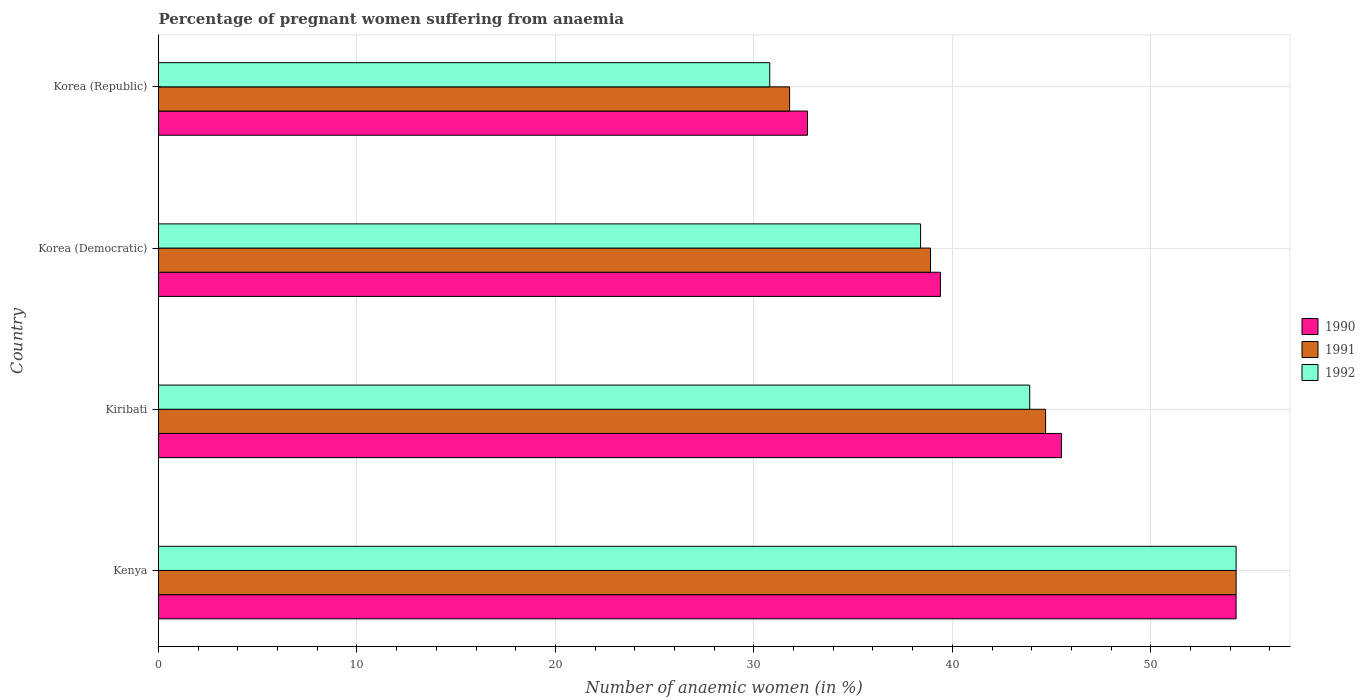How many groups of bars are there?
Give a very brief answer. 4. Are the number of bars per tick equal to the number of legend labels?
Offer a very short reply. Yes. Are the number of bars on each tick of the Y-axis equal?
Keep it short and to the point. Yes. How many bars are there on the 3rd tick from the bottom?
Provide a short and direct response. 3. What is the label of the 1st group of bars from the top?
Offer a terse response. Korea (Republic). In how many cases, is the number of bars for a given country not equal to the number of legend labels?
Make the answer very short. 0. What is the number of anaemic women in 1990 in Kenya?
Give a very brief answer. 54.3. Across all countries, what is the maximum number of anaemic women in 1992?
Provide a succinct answer. 54.3. Across all countries, what is the minimum number of anaemic women in 1992?
Your answer should be very brief. 30.8. In which country was the number of anaemic women in 1990 maximum?
Give a very brief answer. Kenya. In which country was the number of anaemic women in 1991 minimum?
Offer a terse response. Korea (Republic). What is the total number of anaemic women in 1992 in the graph?
Make the answer very short. 167.4. What is the difference between the number of anaemic women in 1992 in Kiribati and that in Korea (Republic)?
Your response must be concise. 13.1. What is the difference between the number of anaemic women in 1992 in Korea (Democratic) and the number of anaemic women in 1990 in Kenya?
Ensure brevity in your answer.  -15.9. What is the average number of anaemic women in 1992 per country?
Your answer should be very brief. 41.85. What is the difference between the number of anaemic women in 1991 and number of anaemic women in 1990 in Kenya?
Offer a very short reply. 0. In how many countries, is the number of anaemic women in 1990 greater than 6 %?
Provide a succinct answer. 4. What is the ratio of the number of anaemic women in 1991 in Kiribati to that in Korea (Democratic)?
Your answer should be compact. 1.15. Is the number of anaemic women in 1992 in Kenya less than that in Korea (Republic)?
Ensure brevity in your answer.  No. What is the difference between the highest and the second highest number of anaemic women in 1991?
Your response must be concise. 9.6. What is the difference between the highest and the lowest number of anaemic women in 1991?
Provide a succinct answer. 22.5. In how many countries, is the number of anaemic women in 1992 greater than the average number of anaemic women in 1992 taken over all countries?
Your answer should be compact. 2. What does the 3rd bar from the top in Kenya represents?
Keep it short and to the point. 1990. Are all the bars in the graph horizontal?
Provide a short and direct response. Yes. How many countries are there in the graph?
Your answer should be compact. 4. What is the difference between two consecutive major ticks on the X-axis?
Provide a short and direct response. 10. Are the values on the major ticks of X-axis written in scientific E-notation?
Provide a short and direct response. No. Where does the legend appear in the graph?
Your answer should be compact. Center right. How are the legend labels stacked?
Provide a short and direct response. Vertical. What is the title of the graph?
Your response must be concise. Percentage of pregnant women suffering from anaemia. Does "2002" appear as one of the legend labels in the graph?
Your response must be concise. No. What is the label or title of the X-axis?
Give a very brief answer. Number of anaemic women (in %). What is the label or title of the Y-axis?
Ensure brevity in your answer.  Country. What is the Number of anaemic women (in %) of 1990 in Kenya?
Your answer should be compact. 54.3. What is the Number of anaemic women (in %) in 1991 in Kenya?
Keep it short and to the point. 54.3. What is the Number of anaemic women (in %) of 1992 in Kenya?
Offer a very short reply. 54.3. What is the Number of anaemic women (in %) in 1990 in Kiribati?
Your answer should be compact. 45.5. What is the Number of anaemic women (in %) of 1991 in Kiribati?
Make the answer very short. 44.7. What is the Number of anaemic women (in %) in 1992 in Kiribati?
Ensure brevity in your answer.  43.9. What is the Number of anaemic women (in %) in 1990 in Korea (Democratic)?
Your answer should be very brief. 39.4. What is the Number of anaemic women (in %) of 1991 in Korea (Democratic)?
Make the answer very short. 38.9. What is the Number of anaemic women (in %) in 1992 in Korea (Democratic)?
Your answer should be compact. 38.4. What is the Number of anaemic women (in %) in 1990 in Korea (Republic)?
Your answer should be very brief. 32.7. What is the Number of anaemic women (in %) of 1991 in Korea (Republic)?
Provide a short and direct response. 31.8. What is the Number of anaemic women (in %) in 1992 in Korea (Republic)?
Your answer should be compact. 30.8. Across all countries, what is the maximum Number of anaemic women (in %) of 1990?
Make the answer very short. 54.3. Across all countries, what is the maximum Number of anaemic women (in %) in 1991?
Your answer should be compact. 54.3. Across all countries, what is the maximum Number of anaemic women (in %) in 1992?
Make the answer very short. 54.3. Across all countries, what is the minimum Number of anaemic women (in %) of 1990?
Ensure brevity in your answer.  32.7. Across all countries, what is the minimum Number of anaemic women (in %) in 1991?
Give a very brief answer. 31.8. Across all countries, what is the minimum Number of anaemic women (in %) of 1992?
Keep it short and to the point. 30.8. What is the total Number of anaemic women (in %) of 1990 in the graph?
Your answer should be compact. 171.9. What is the total Number of anaemic women (in %) of 1991 in the graph?
Offer a terse response. 169.7. What is the total Number of anaemic women (in %) in 1992 in the graph?
Ensure brevity in your answer.  167.4. What is the difference between the Number of anaemic women (in %) of 1992 in Kenya and that in Kiribati?
Offer a very short reply. 10.4. What is the difference between the Number of anaemic women (in %) of 1990 in Kenya and that in Korea (Democratic)?
Your response must be concise. 14.9. What is the difference between the Number of anaemic women (in %) in 1991 in Kenya and that in Korea (Democratic)?
Your answer should be compact. 15.4. What is the difference between the Number of anaemic women (in %) in 1990 in Kenya and that in Korea (Republic)?
Make the answer very short. 21.6. What is the difference between the Number of anaemic women (in %) of 1991 in Kenya and that in Korea (Republic)?
Make the answer very short. 22.5. What is the difference between the Number of anaemic women (in %) in 1991 in Kiribati and that in Korea (Democratic)?
Provide a short and direct response. 5.8. What is the difference between the Number of anaemic women (in %) of 1991 in Kiribati and that in Korea (Republic)?
Ensure brevity in your answer.  12.9. What is the difference between the Number of anaemic women (in %) in 1991 in Korea (Democratic) and that in Korea (Republic)?
Offer a terse response. 7.1. What is the difference between the Number of anaemic women (in %) in 1992 in Korea (Democratic) and that in Korea (Republic)?
Offer a very short reply. 7.6. What is the difference between the Number of anaemic women (in %) of 1990 in Kenya and the Number of anaemic women (in %) of 1992 in Kiribati?
Ensure brevity in your answer.  10.4. What is the difference between the Number of anaemic women (in %) of 1991 in Kenya and the Number of anaemic women (in %) of 1992 in Korea (Democratic)?
Keep it short and to the point. 15.9. What is the difference between the Number of anaemic women (in %) in 1990 in Kenya and the Number of anaemic women (in %) in 1991 in Korea (Republic)?
Make the answer very short. 22.5. What is the difference between the Number of anaemic women (in %) in 1991 in Kiribati and the Number of anaemic women (in %) in 1992 in Korea (Democratic)?
Your answer should be compact. 6.3. What is the difference between the Number of anaemic women (in %) in 1990 in Kiribati and the Number of anaemic women (in %) in 1991 in Korea (Republic)?
Keep it short and to the point. 13.7. What is the difference between the Number of anaemic women (in %) of 1991 in Kiribati and the Number of anaemic women (in %) of 1992 in Korea (Republic)?
Provide a succinct answer. 13.9. What is the average Number of anaemic women (in %) in 1990 per country?
Ensure brevity in your answer.  42.98. What is the average Number of anaemic women (in %) of 1991 per country?
Offer a terse response. 42.42. What is the average Number of anaemic women (in %) of 1992 per country?
Your answer should be compact. 41.85. What is the difference between the Number of anaemic women (in %) of 1990 and Number of anaemic women (in %) of 1991 in Kiribati?
Provide a short and direct response. 0.8. What is the difference between the Number of anaemic women (in %) of 1990 and Number of anaemic women (in %) of 1991 in Korea (Republic)?
Offer a very short reply. 0.9. What is the difference between the Number of anaemic women (in %) of 1990 and Number of anaemic women (in %) of 1992 in Korea (Republic)?
Your response must be concise. 1.9. What is the ratio of the Number of anaemic women (in %) of 1990 in Kenya to that in Kiribati?
Ensure brevity in your answer.  1.19. What is the ratio of the Number of anaemic women (in %) of 1991 in Kenya to that in Kiribati?
Offer a terse response. 1.21. What is the ratio of the Number of anaemic women (in %) of 1992 in Kenya to that in Kiribati?
Ensure brevity in your answer.  1.24. What is the ratio of the Number of anaemic women (in %) of 1990 in Kenya to that in Korea (Democratic)?
Your answer should be very brief. 1.38. What is the ratio of the Number of anaemic women (in %) in 1991 in Kenya to that in Korea (Democratic)?
Make the answer very short. 1.4. What is the ratio of the Number of anaemic women (in %) of 1992 in Kenya to that in Korea (Democratic)?
Offer a terse response. 1.41. What is the ratio of the Number of anaemic women (in %) of 1990 in Kenya to that in Korea (Republic)?
Ensure brevity in your answer.  1.66. What is the ratio of the Number of anaemic women (in %) in 1991 in Kenya to that in Korea (Republic)?
Provide a short and direct response. 1.71. What is the ratio of the Number of anaemic women (in %) in 1992 in Kenya to that in Korea (Republic)?
Provide a succinct answer. 1.76. What is the ratio of the Number of anaemic women (in %) in 1990 in Kiribati to that in Korea (Democratic)?
Offer a very short reply. 1.15. What is the ratio of the Number of anaemic women (in %) in 1991 in Kiribati to that in Korea (Democratic)?
Keep it short and to the point. 1.15. What is the ratio of the Number of anaemic women (in %) of 1992 in Kiribati to that in Korea (Democratic)?
Provide a succinct answer. 1.14. What is the ratio of the Number of anaemic women (in %) in 1990 in Kiribati to that in Korea (Republic)?
Your response must be concise. 1.39. What is the ratio of the Number of anaemic women (in %) in 1991 in Kiribati to that in Korea (Republic)?
Make the answer very short. 1.41. What is the ratio of the Number of anaemic women (in %) in 1992 in Kiribati to that in Korea (Republic)?
Your answer should be very brief. 1.43. What is the ratio of the Number of anaemic women (in %) in 1990 in Korea (Democratic) to that in Korea (Republic)?
Offer a terse response. 1.2. What is the ratio of the Number of anaemic women (in %) of 1991 in Korea (Democratic) to that in Korea (Republic)?
Your response must be concise. 1.22. What is the ratio of the Number of anaemic women (in %) in 1992 in Korea (Democratic) to that in Korea (Republic)?
Your answer should be compact. 1.25. What is the difference between the highest and the lowest Number of anaemic women (in %) in 1990?
Keep it short and to the point. 21.6. What is the difference between the highest and the lowest Number of anaemic women (in %) in 1992?
Give a very brief answer. 23.5. 